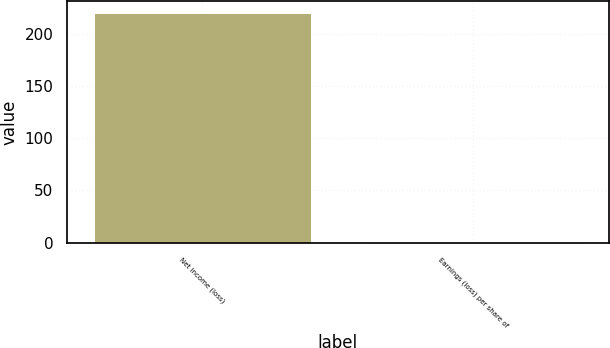<chart> <loc_0><loc_0><loc_500><loc_500><bar_chart><fcel>Net income (loss)<fcel>Earnings (loss) per share of<nl><fcel>220<fcel>0.27<nl></chart> 